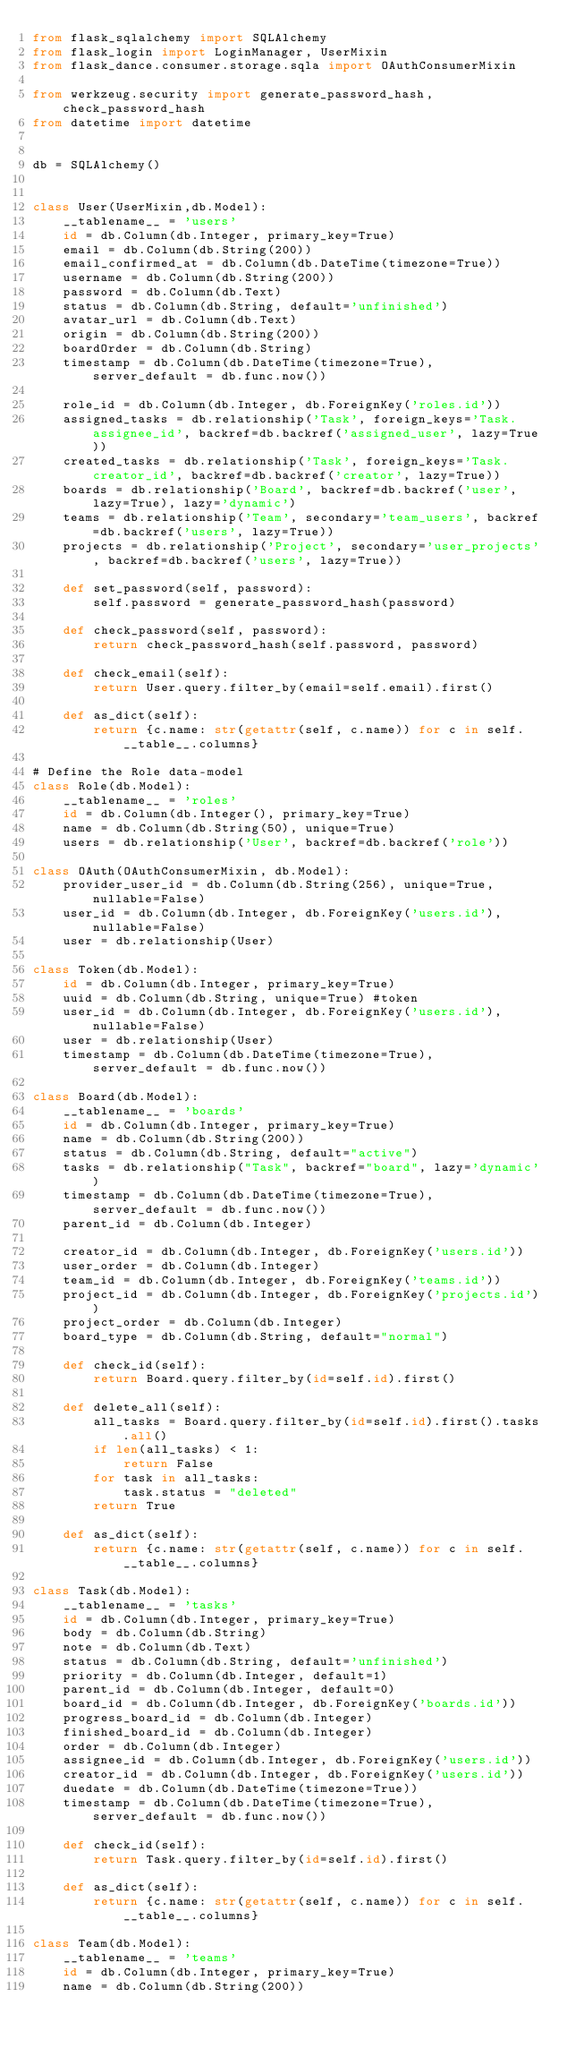<code> <loc_0><loc_0><loc_500><loc_500><_Python_>from flask_sqlalchemy import SQLAlchemy
from flask_login import LoginManager, UserMixin
from flask_dance.consumer.storage.sqla import OAuthConsumerMixin

from werkzeug.security import generate_password_hash, check_password_hash
from datetime import datetime


db = SQLAlchemy()


class User(UserMixin,db.Model):
    __tablename__ = 'users'
    id = db.Column(db.Integer, primary_key=True)
    email = db.Column(db.String(200))
    email_confirmed_at = db.Column(db.DateTime(timezone=True))
    username = db.Column(db.String(200))
    password = db.Column(db.Text)
    status = db.Column(db.String, default='unfinished')
    avatar_url = db.Column(db.Text)
    origin = db.Column(db.String(200))
    boardOrder = db.Column(db.String)
    timestamp = db.Column(db.DateTime(timezone=True), server_default = db.func.now())

    role_id = db.Column(db.Integer, db.ForeignKey('roles.id'))
    assigned_tasks = db.relationship('Task', foreign_keys='Task.assignee_id', backref=db.backref('assigned_user', lazy=True))
    created_tasks = db.relationship('Task', foreign_keys='Task.creator_id', backref=db.backref('creator', lazy=True))
    boards = db.relationship('Board', backref=db.backref('user', lazy=True), lazy='dynamic')
    teams = db.relationship('Team', secondary='team_users', backref=db.backref('users', lazy=True))
    projects = db.relationship('Project', secondary='user_projects', backref=db.backref('users', lazy=True))

    def set_password(self, password):
        self.password = generate_password_hash(password)

    def check_password(self, password):
        return check_password_hash(self.password, password)

    def check_email(self):
        return User.query.filter_by(email=self.email).first()

    def as_dict(self):
        return {c.name: str(getattr(self, c.name)) for c in self.__table__.columns}
        
# Define the Role data-model
class Role(db.Model):
    __tablename__ = 'roles'
    id = db.Column(db.Integer(), primary_key=True)
    name = db.Column(db.String(50), unique=True)
    users = db.relationship('User', backref=db.backref('role'))

class OAuth(OAuthConsumerMixin, db.Model):
    provider_user_id = db.Column(db.String(256), unique=True, nullable=False)
    user_id = db.Column(db.Integer, db.ForeignKey('users.id'), nullable=False)
    user = db.relationship(User)

class Token(db.Model):
    id = db.Column(db.Integer, primary_key=True)
    uuid = db.Column(db.String, unique=True) #token
    user_id = db.Column(db.Integer, db.ForeignKey('users.id'), nullable=False)
    user = db.relationship(User)
    timestamp = db.Column(db.DateTime(timezone=True), server_default = db.func.now())

class Board(db.Model):
    __tablename__ = 'boards'
    id = db.Column(db.Integer, primary_key=True)
    name = db.Column(db.String(200))
    status = db.Column(db.String, default="active")
    tasks = db.relationship("Task", backref="board", lazy='dynamic')
    timestamp = db.Column(db.DateTime(timezone=True), server_default = db.func.now())
    parent_id = db.Column(db.Integer)

    creator_id = db.Column(db.Integer, db.ForeignKey('users.id'))
    user_order = db.Column(db.Integer)
    team_id = db.Column(db.Integer, db.ForeignKey('teams.id'))
    project_id = db.Column(db.Integer, db.ForeignKey('projects.id'))
    project_order = db.Column(db.Integer)
    board_type = db.Column(db.String, default="normal")

    def check_id(self):
        return Board.query.filter_by(id=self.id).first()

    def delete_all(self):
        all_tasks = Board.query.filter_by(id=self.id).first().tasks.all()
        if len(all_tasks) < 1:
            return False
        for task in all_tasks:
            task.status = "deleted"
        return True

    def as_dict(self):
        return {c.name: str(getattr(self, c.name)) for c in self.__table__.columns}

class Task(db.Model):
    __tablename__ = 'tasks'
    id = db.Column(db.Integer, primary_key=True)
    body = db.Column(db.String)
    note = db.Column(db.Text)
    status = db.Column(db.String, default='unfinished')
    priority = db.Column(db.Integer, default=1)
    parent_id = db.Column(db.Integer, default=0)
    board_id = db.Column(db.Integer, db.ForeignKey('boards.id'))
    progress_board_id = db.Column(db.Integer)
    finished_board_id = db.Column(db.Integer)
    order = db.Column(db.Integer)
    assignee_id = db.Column(db.Integer, db.ForeignKey('users.id'))
    creator_id = db.Column(db.Integer, db.ForeignKey('users.id'))
    duedate = db.Column(db.DateTime(timezone=True))
    timestamp = db.Column(db.DateTime(timezone=True), server_default = db.func.now())

    def check_id(self):
        return Task.query.filter_by(id=self.id).first()
    
    def as_dict(self):
        return {c.name: str(getattr(self, c.name)) for c in self.__table__.columns}

class Team(db.Model):
    __tablename__ = 'teams'
    id = db.Column(db.Integer, primary_key=True)
    name = db.Column(db.String(200))</code> 